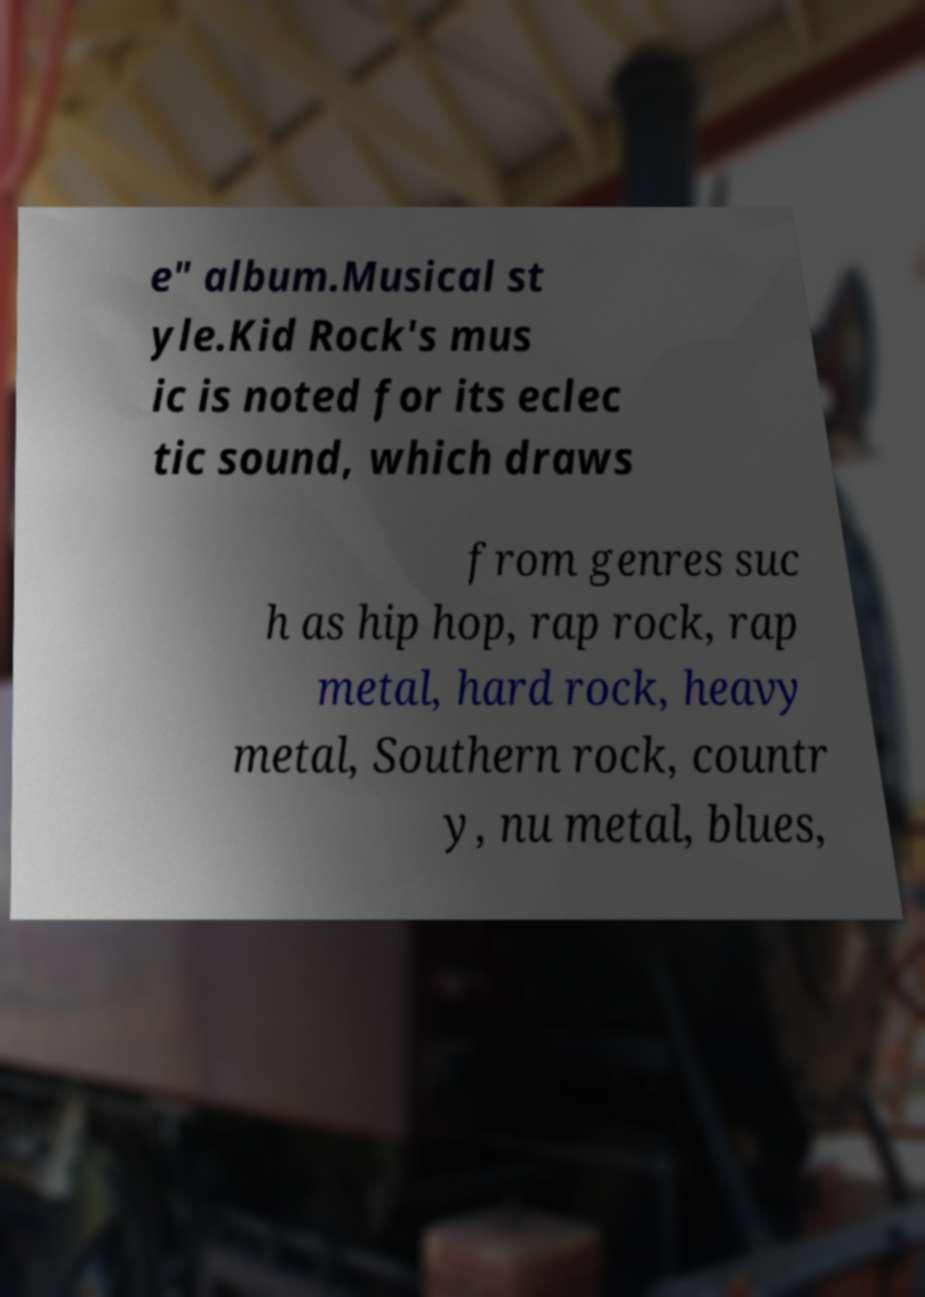I need the written content from this picture converted into text. Can you do that? e" album.Musical st yle.Kid Rock's mus ic is noted for its eclec tic sound, which draws from genres suc h as hip hop, rap rock, rap metal, hard rock, heavy metal, Southern rock, countr y, nu metal, blues, 